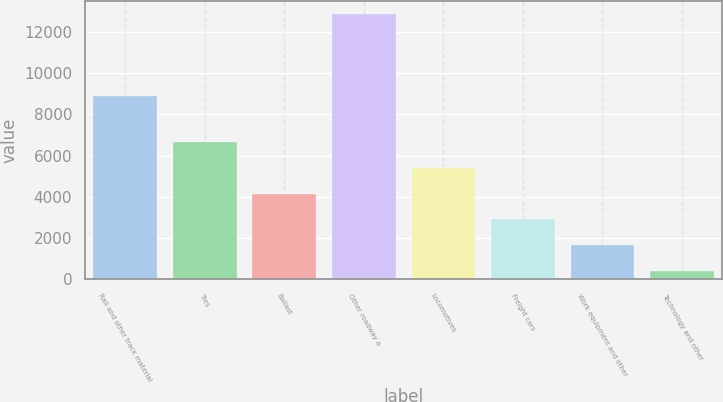Convert chart. <chart><loc_0><loc_0><loc_500><loc_500><bar_chart><fcel>Rail and other track material<fcel>Ties<fcel>Ballast<fcel>Other roadway a<fcel>Locomotives<fcel>Freight cars<fcel>Work equipment and other<fcel>Technology and other<nl><fcel>8891<fcel>6647.5<fcel>4158.5<fcel>12870<fcel>5403<fcel>2914<fcel>1669.5<fcel>425<nl></chart> 